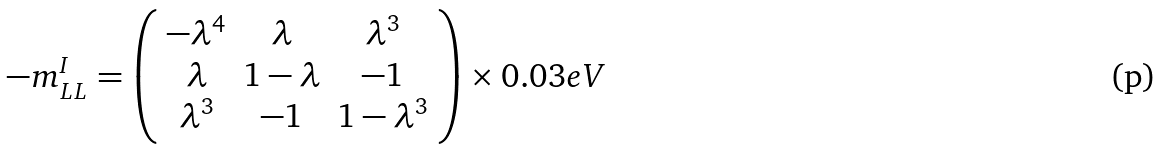Convert formula to latex. <formula><loc_0><loc_0><loc_500><loc_500>- m _ { L L } ^ { I } = \left ( \begin{array} { c c c } - \lambda ^ { 4 } & \lambda & \lambda ^ { 3 } \\ \lambda & 1 - \lambda & - 1 \\ \lambda ^ { 3 } & - 1 & 1 - \lambda ^ { 3 } \end{array} \right ) \times 0 . 0 3 e V</formula> 